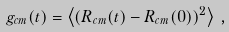Convert formula to latex. <formula><loc_0><loc_0><loc_500><loc_500>g _ { c m } ( t ) = \left \langle ( { R } _ { c m } ( t ) - { R } _ { c m } ( 0 ) ) ^ { 2 } \right \rangle \, ,</formula> 